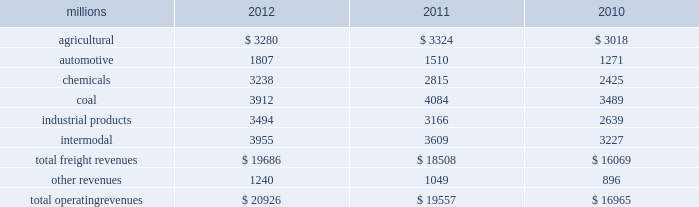Notes to the consolidated financial statements union pacific corporation and subsidiary companies for purposes of this report , unless the context otherwise requires , all references herein to the 201ccorporation 201d , 201cupc 201d , 201cwe 201d , 201cus 201d , and 201cour 201d mean union pacific corporation and its subsidiaries , including union pacific railroad company , which will be separately referred to herein as 201cuprr 201d or the 201crailroad 201d .
Nature of operations operations and segmentation 2013 we are a class i railroad operating in the u.s .
Our network includes 31868 route miles , linking pacific coast and gulf coast ports with the midwest and eastern u.s .
Gateways and providing several corridors to key mexican gateways .
We own 26020 miles and operate on the remainder pursuant to trackage rights or leases .
We serve the western two-thirds of the country and maintain coordinated schedules with other rail carriers for the handling of freight to and from the atlantic coast , the pacific coast , the southeast , the southwest , canada , and mexico .
Export and import traffic is moved through gulf coast and pacific coast ports and across the mexican and canadian borders .
The railroad , along with its subsidiaries and rail affiliates , is our one reportable operating segment .
Although we provide and review revenue by commodity group , we analyze the net financial results of the railroad as one segment due to the integrated nature of our rail network .
The table provides freight revenue by commodity group : millions 2012 2011 2010 .
Although our revenues are principally derived from customers domiciled in the u.s. , the ultimate points of origination or destination for some products transported by us are outside the u.s .
Each of our commodity groups includes revenue from shipments to and from mexico .
Included in the above table are revenues from our mexico business which amounted to $ 1.9 billion in 2012 , $ 1.8 billion in 2011 , and $ 1.6 billion in 2010 .
Basis of presentation 2013 the consolidated financial statements are presented in accordance with accounting principles generally accepted in the u.s .
( gaap ) as codified in the financial accounting standards board ( fasb ) accounting standards codification ( asc ) .
Significant accounting policies principles of consolidation 2013 the consolidated financial statements include the accounts of union pacific corporation and all of its subsidiaries .
Investments in affiliated companies ( 20% ( 20 % ) to 50% ( 50 % ) owned ) are accounted for using the equity method of accounting .
All intercompany transactions are eliminated .
We currently have no less than majority-owned investments that require consolidation under variable interest entity requirements .
Cash and cash equivalents 2013 cash equivalents consist of investments with original maturities of three months or less .
Accounts receivable 2013 accounts receivable includes receivables reduced by an allowance for doubtful accounts .
The allowance is based upon historical losses , credit worthiness of customers , and current economic conditions .
Receivables not expected to be collected in one year and the associated allowances are classified as other assets in our consolidated statements of financial position. .
What percentage of total freight revenues was the industrial products commodity group in 2012? 
Computations: (3494 / 19686)
Answer: 0.17749. 